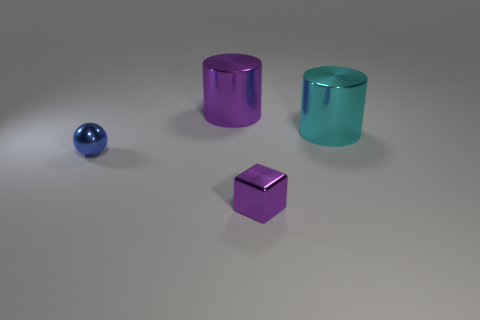Add 3 purple things. How many objects exist? 7 Subtract all cubes. How many objects are left? 3 Add 3 cyan cylinders. How many cyan cylinders are left? 4 Add 2 blue metal objects. How many blue metal objects exist? 3 Subtract 0 green cylinders. How many objects are left? 4 Subtract all small cyan matte balls. Subtract all large cylinders. How many objects are left? 2 